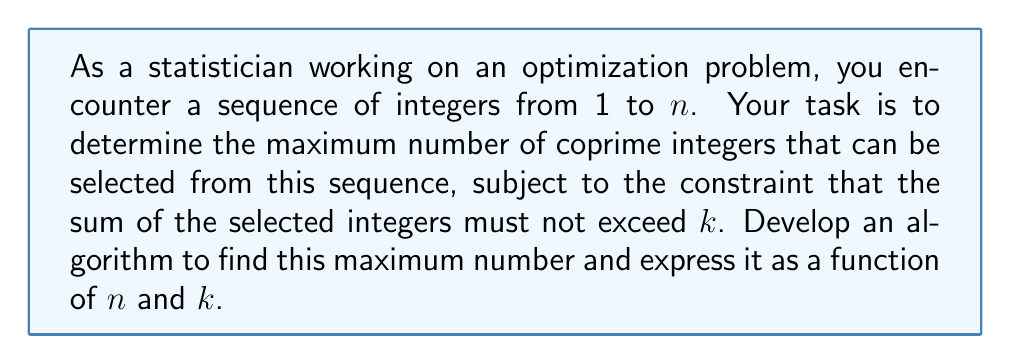Show me your answer to this math problem. To solve this problem, we need to approach it step-by-step:

1) First, recall that two integers are coprime if their greatest common divisor (GCD) is 1.

2) Observe that all odd numbers are coprime to each other. This is because the GCD of any two odd numbers is always odd, and the only odd divisor they all share is 1.

3) The number 2 is coprime to all odd numbers.

4) Therefore, to maximize the number of coprime integers, we should select 2 and as many odd numbers as possible.

5) The odd numbers in the sequence are 1, 3, 5, ..., up to the largest odd number not exceeding $n$.

6) Let's define a function $f(n,k)$ that returns the maximum number of coprime integers we can select from 1 to $n$ with sum not exceeding $k$.

7) We can express $f(n,k)$ recursively:

   $$f(n,k) = \begin{cases}
   0 & \text{if } k < 1 \\
   1 + f(n, k-2) & \text{if } k \geq 2 \text{ and } n \geq 2 \\
   1 + f(n-2, k-n) & \text{if } k \geq n \text{ and } n \text{ is odd} \\
   f(n-1, k) & \text{if } n \text{ is even and } n > 2
   \end{cases}$$

8) This recursive function can be optimized using dynamic programming for efficient computation.

9) The base case is when $k < 1$, where we can't select any number.

10) If $k \geq 2$ and $n \geq 2$, we always include 2 in our selection and recurse with $k-2$.

11) If $k \geq n$ and $n$ is odd, we include $n$ and recurse with the next odd number ($n-2$) and the remaining sum ($k-n$).

12) If $n$ is even and greater than 2, we skip it and recurse with $n-1$.

13) The maximum number of coprime integers will be the result of $f(n,k)$.
Answer: The maximum number of coprime integers in a sequence from 1 to $n$ with sum not exceeding $k$ is given by the function $f(n,k)$, where:

$$f(n,k) = \begin{cases}
0 & \text{if } k < 1 \\
1 + f(n, k-2) & \text{if } k \geq 2 \text{ and } n \geq 2 \\
1 + f(n-2, k-n) & \text{if } k \geq n \text{ and } n \text{ is odd} \\
f(n-1, k) & \text{if } n \text{ is even and } n > 2
\end{cases}$$

This function can be implemented using dynamic programming for efficient computation. 